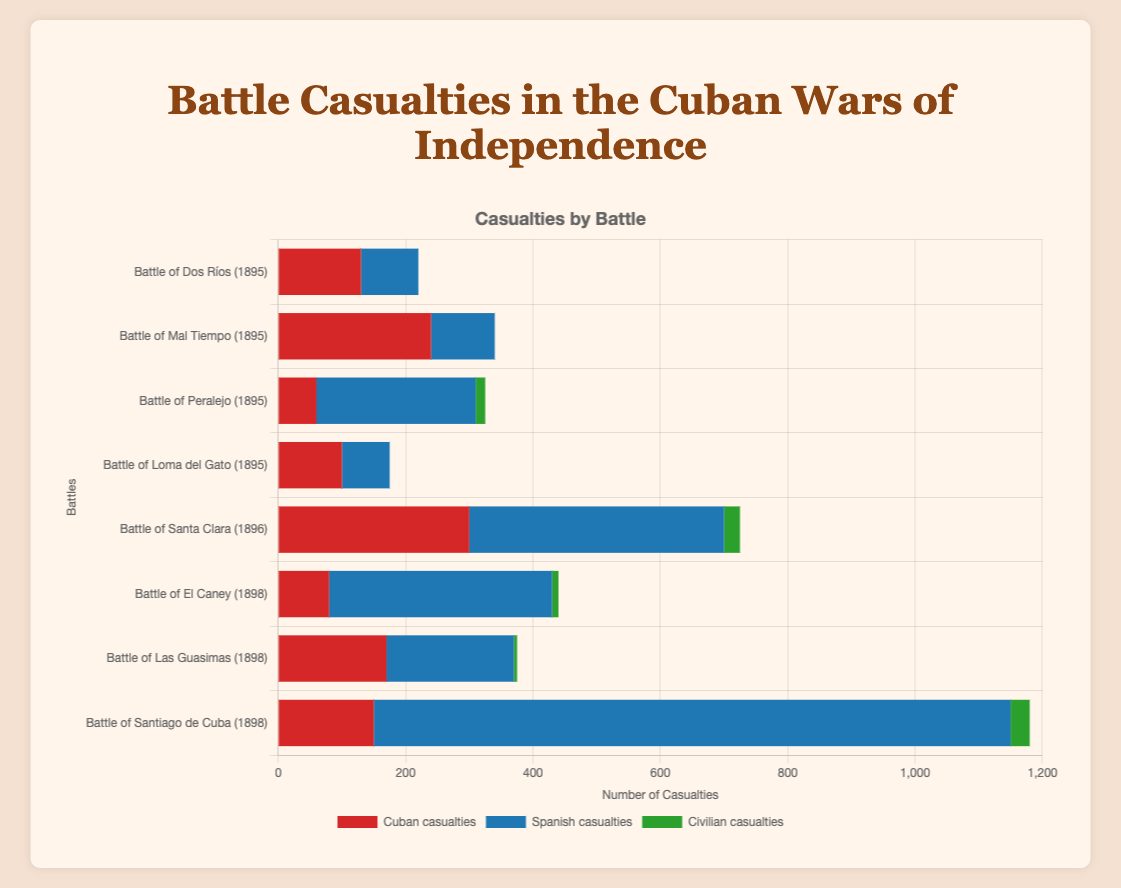Which battle had the highest number of Spanish casualties? Identify the bars representing Spanish casualties and locate the tallest one. The highest bar for Spanish casualties is for the Battle of Santiago de Cuba.
Answer: Battle of Santiago de Cuba Which battles in 1895 had more Cuban casualties than Spanish casualties? Identify battles that occurred in 1895 and compare the lengths of the Cuban casualty bars to the Spanish casualty bars. Dos Ríos, Mal Tiempo, and Loma del Gato had more Cuban casualties than Spanish casualties.
Answer: Dos Ríos, Mal Tiempo, Loma del Gato What is the total number of casualties (Cuban, Spanish, and Civilian) in the Battle of Santa Clara? Sum the heights of the bars for Cuban, Spanish, and Civilian casualties for the Battle of Santa Clara. 300 (Cuban) + 400 (Spanish) + 25 (Civilian) = 725
Answer: 725 Which battle had the lowest civilian casualties? Look at the bars representing civilian casualties and find the shortest one. Multiple battles have 0 civilian casualties: Dos Ríos, Mal Tiempo, Loma del Gato.
Answer: Dos Ríos, Mal Tiempo, Loma del Gato How does the number of Cuban casualties in the Battle of El Caney compare to those in the Battle of Santiago de Cuba? Compare the heights of the bars for Cuban casualties in the Battle of El Caney and Santiago de Cuba. El Caney has fewer Cuban casualties (80) compared to Santiago de Cuba (150).
Answer: Fewer in El Caney What is the average number of Spanish casualties in the battles of 1896 and 1898? Sum the Spanish casualties for battles in these years and divide by the number of battles. (400 + 350 + 200 + 1000) / 4 = 1950 / 4 = 487.5
Answer: 487.5 In which battle were civilian casualties the highest, and what were those casualties? Identify the highest bar representing civilian casualties. The Battle of Santiago de Cuba had the highest civilian casualties at 30.
Answer: Battle of Santiago de Cuba, 30 How do total casualties in the Battle of Dos Ríos compare to those in the Battle of Peralejo? Sum all types of casualties for each battle and compare. Dos Ríos: 130 + 90 + 0 = 220. Peralejo: 60 + 250 + 15 = 325. Peralejo has more total casualties.
Answer: More in Peralejo 